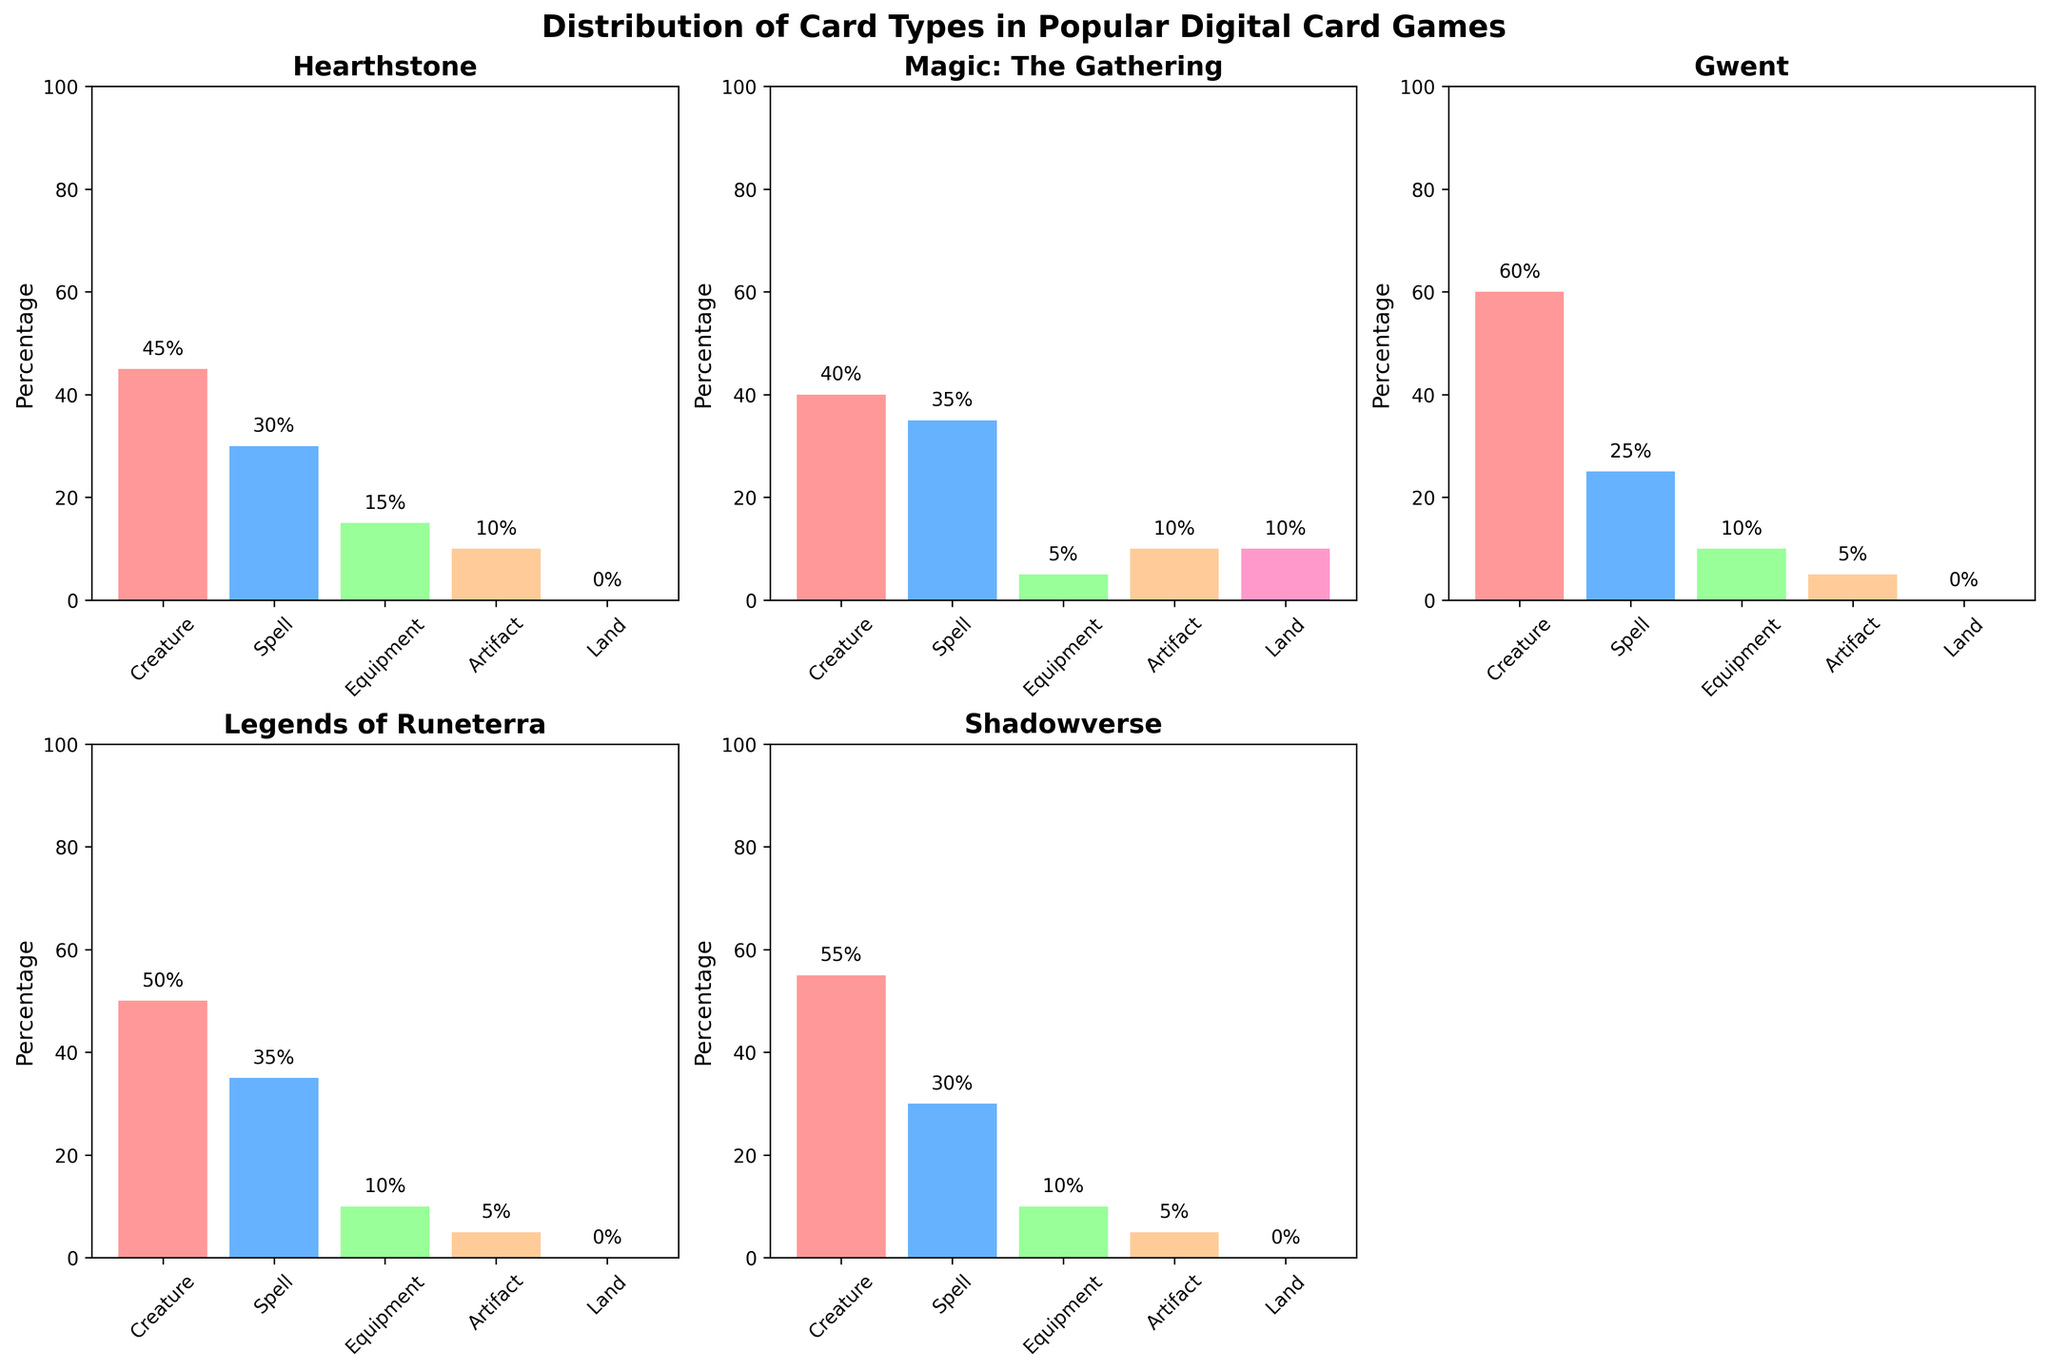What is the title of the figure? The title is located at the top of the figure in bold text.
Answer: Distribution of Card Types in Popular Digital Card Games How many games are displayed in the subplots? There are six subplots based on the visual elements, each representing a game.
Answer: Six Which game has the highest percentage of 'Creature' cards? Locate the specific bar labeled 'Creature' in the subplots and compare their heights. Gwent has the highest bar for 'Creature' with 60%.
Answer: Gwent Are there any games that do not include 'Land' cards? Look at the 'Land' category in each subplot. Hearthstone, Gwent, Legends of Runeterra, and Shadowverse have 0% 'Land' cards.
Answer: Four What is the combined percentage of 'Spell' and 'Equipment' cards in Hearthstone? Add the 'Spell' percentage (30) and 'Equipment' percentage (15) in the Hearthstone subplot. 30 + 15 = 45
Answer: 45% Which game has the smallest percentage of 'Equipment' cards? Compare the height of the 'Equipment' bars in each subplot. Magic: The Gathering has the smallest bar at 5%.
Answer: Magic: The Gathering Do any games have an equal percentage of 'Artifact' cards? Look for the 'Artifact' bars across all subplots. Hearthstone, Magic: The Gathering, Legends of Runeterra, and Shadowverse each have 10%.
Answer: Yes Which game has the highest diversity in card type percentages (i.e., the least uniform distribution)? The game with the highest variation in bar heights represents the highest diversity. Hearthstone's bars vary from 45% (Creature) to 0% (Land).
Answer: Hearthstone What's the total percentage of non-creature cards in Legends of Runeterra? Sum the percentages of 'Spell', 'Equipment', 'Artifact', and 'Land' in Legends of Runeterra. 35 + 10 + 5 + 0 = 50
Answer: 50% In Yu-Gi-Oh! Duel Links, what is the difference in percentage between 'Creature' and 'Spell' cards? Subtract the 'Creature' percentage (35) from the 'Spell' percentage (40) in Yu-Gi-Oh! Duel Links. 40 - 35 = 5
Answer: 5% 